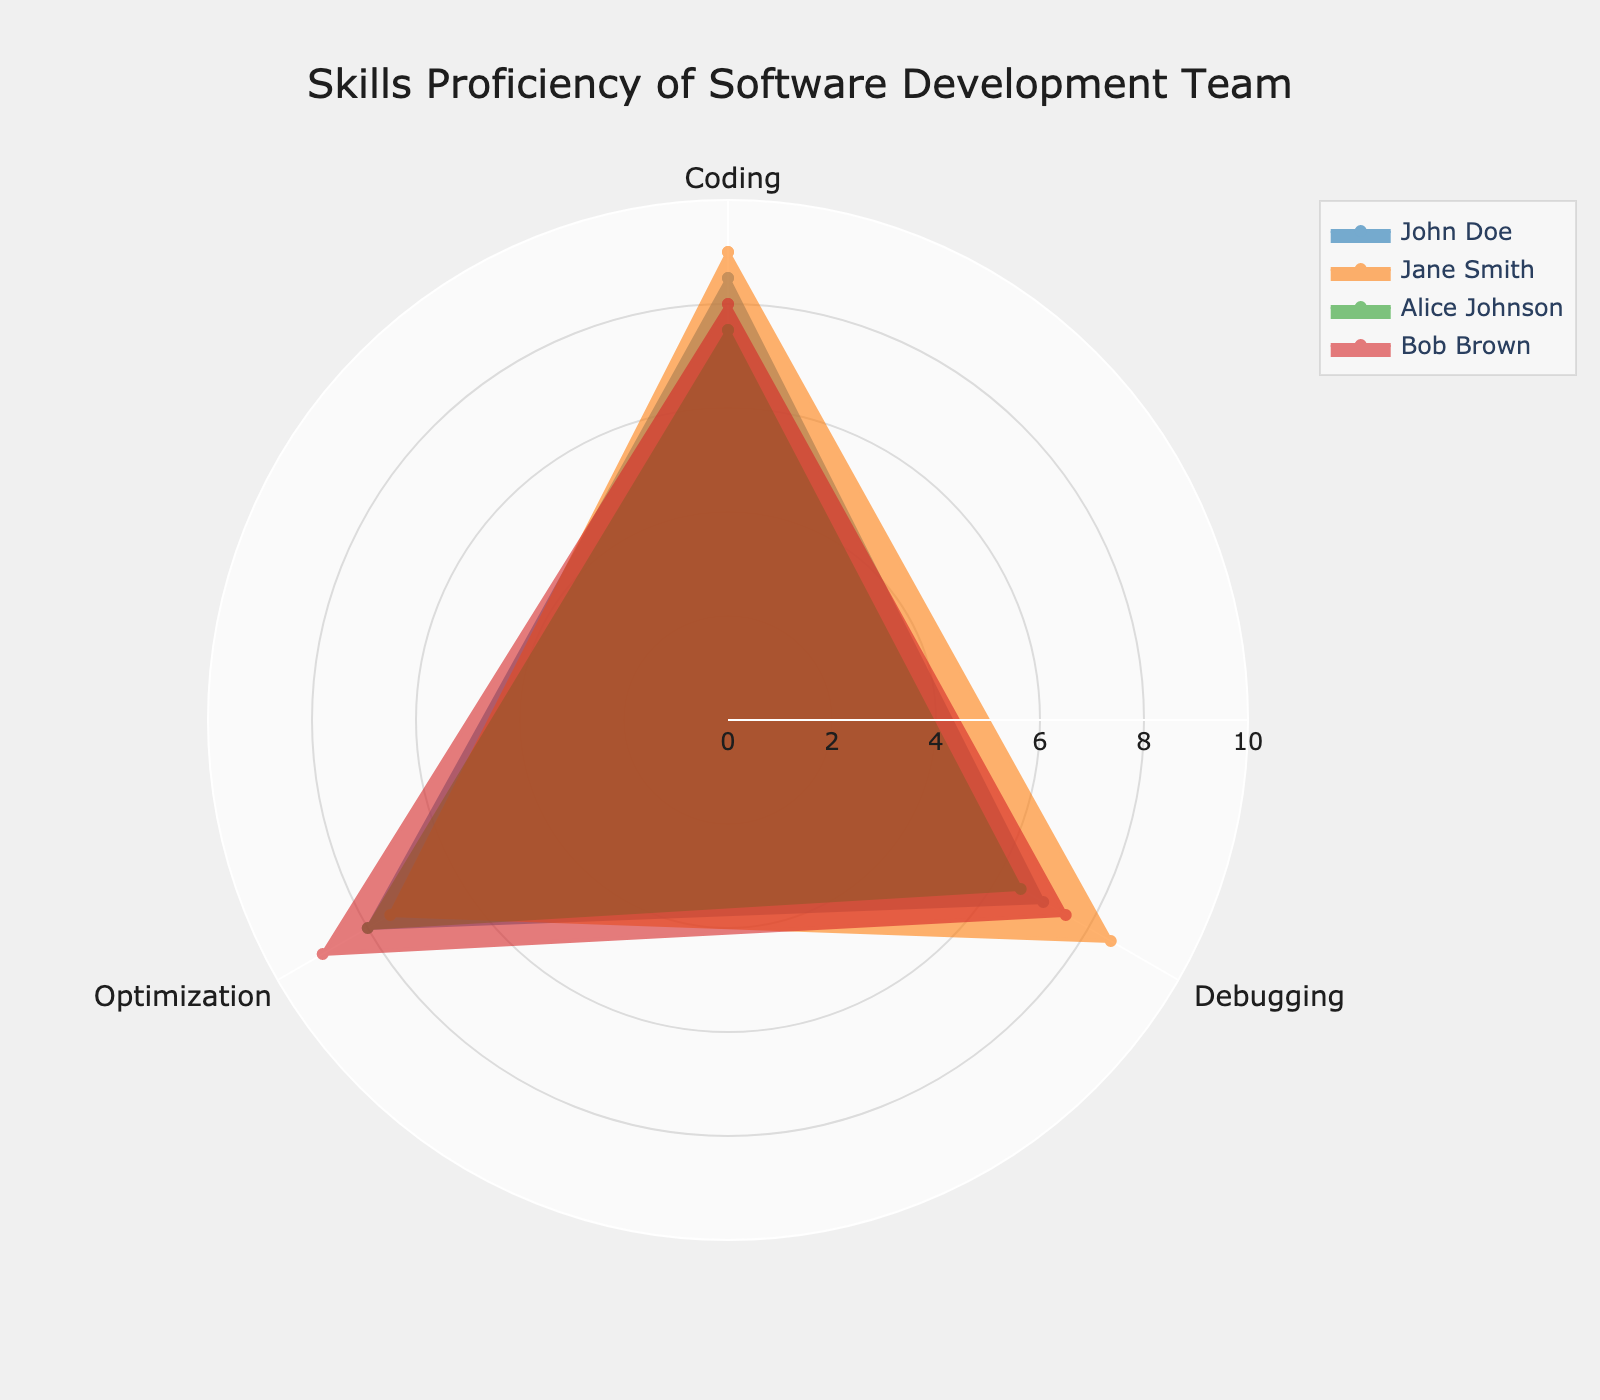Which group has the highest Coding proficiency? Looking at the radar chart, locate the vertices for the Coding proficiency and compare the lengths for each group. Jane Smith has the tallest spike for Coding, indicating she has the highest proficiency.
Answer: Jane Smith What is the average Debugging proficiency of the team? To find the average Debugging score, sum the Debugging values for all individuals and then divide by the number of individuals: (7.0 + 8.5 + 6.5 + 7.5) / 4 = 7.375.
Answer: 7.375 Who has the lowest proficiency in Optimization? Check the Optimization vertices for each individual and identify the shortest spike. Alice Johnson has the lowest proficiency in Optimization with a value of 8.0.
Answer: Alice Johnson What is the combined Optimization score for John Doe and Bob Brown? Sum the Optimization scores for John Doe and Bob Brown: 8.0 + 9.0 = 17.
Answer: 17 Which individual has the most balanced skill proficiency across all three categories? Compare the patterns of all individuals to see who has the least variation in scores. John Doe's skills (8.5, 7.0, 8.0) are closest to each other among all participants, indicating a balanced proficiency.
Answer: John Doe Who has the highest cumulative proficiency score across all three skills? Sum the scores for each individual and compare the totals: 
John Doe: 8.5 + 7.0 + 8.0 = 23.5, 
Jane Smith: 9.0 + 8.5 + 7.5 = 25, 
Alice Johnson: 7.5 + 6.5 + 8.0 = 22, 
Bob Brown: 8.0 + 7.5 + 9.0 = 24.5. 
Jane Smith has the highest cumulative score.
Answer: Jane Smith Are there any individuals with equal scores in any two categories? Check for individuals whose vertices overlap in any two categories. None of the scores overlap exactly for any individual across the given categories.
Answer: No Which two groups have the most similar skill proficiency in Coding? Compare the Coding values for each individual and find the pair with the smallest difference. John Doe (8.5) and Bob Brown (8.0) have the closest values.
Answer: John Doe and Bob Brown By how much does Jane Smith's Debugging proficiency exceed Alice Johnson's? Subtract Alice Johnson's Debugging score from Jane Smith's: 8.5 - 6.5 = 2.
Answer: 2 What is the range of Optimization scores for the team? Find the difference between the highest and lowest Optimization values: 9.0 (Bob Brown) - 7.5 (Jane Smith) = 1.5.
Answer: 1.5 